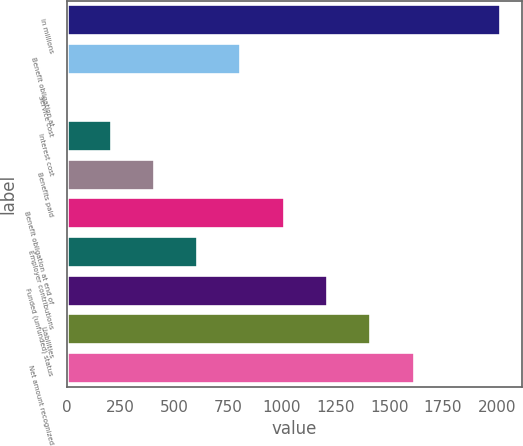<chart> <loc_0><loc_0><loc_500><loc_500><bar_chart><fcel>in millions<fcel>Benefit obligation at<fcel>Service cost<fcel>Interest cost<fcel>Benefits paid<fcel>Benefit obligation at end of<fcel>Employer contributions<fcel>Funded (unfunded) status<fcel>Liabilities<fcel>Net amount recognized<nl><fcel>2016<fcel>807<fcel>1<fcel>202.5<fcel>404<fcel>1008.5<fcel>605.5<fcel>1210<fcel>1411.5<fcel>1613<nl></chart> 